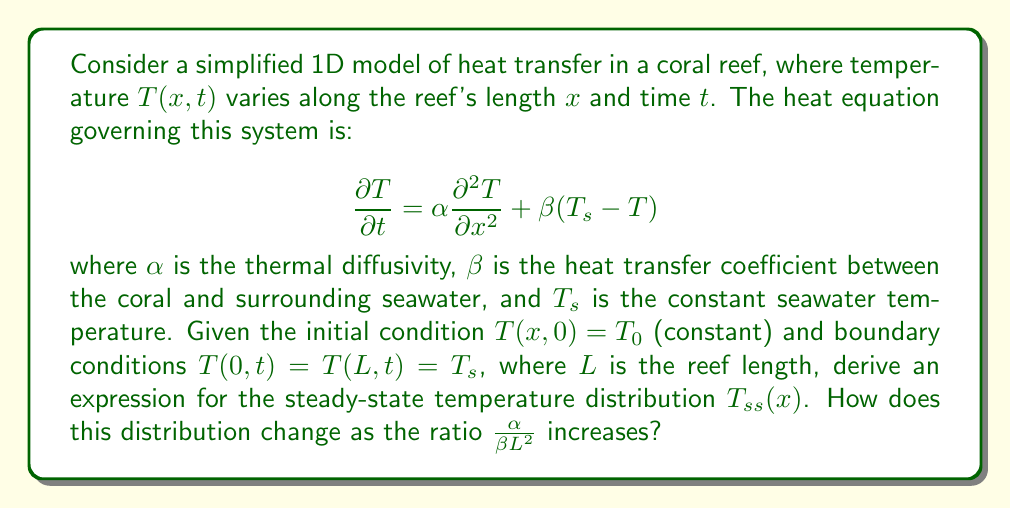What is the answer to this math problem? To solve this problem, we'll follow these steps:

1) For the steady-state solution, $\frac{\partial T}{\partial t} = 0$. The equation becomes:

   $$\alpha \frac{d^2 T_{ss}}{dx^2} + \beta(T_s - T_{ss}) = 0$$

2) Rearrange the equation:

   $$\frac{d^2 T_{ss}}{dx^2} - \frac{\beta}{\alpha}(T_{ss} - T_s) = 0$$

3) Let $\theta = T_{ss} - T_s$ and $k^2 = \frac{\beta}{\alpha}$. The equation simplifies to:

   $$\frac{d^2 \theta}{dx^2} - k^2\theta = 0$$

4) The general solution to this equation is:

   $$\theta = A\sinh(kx) + B\cosh(kx)$$

5) Apply boundary conditions: $\theta(0) = \theta(L) = 0$

   At $x=0$: $0 = B$
   At $x=L$: $0 = A\sinh(kL)$

6) Therefore, $A = 0$ and $B = 0$, leading to:

   $$\theta = 0$$ or $$T_{ss}(x) = T_s$$

7) To analyze how this changes with increasing $\frac{\alpha}{\beta L^2}$, note that:

   $$\frac{\alpha}{\beta L^2} = \frac{1}{k^2L^2}$$

As this ratio increases, $k^2L^2$ decreases, meaning the system approaches the limit where diffusion dominates over heat transfer to the surrounding water. In this case, the steady-state solution remains $T_{ss}(x) = T_s$, but the system will reach this state more quickly.
Answer: $T_{ss}(x) = T_s$; As $\frac{\alpha}{\beta L^2}$ increases, the steady-state is reached faster. 